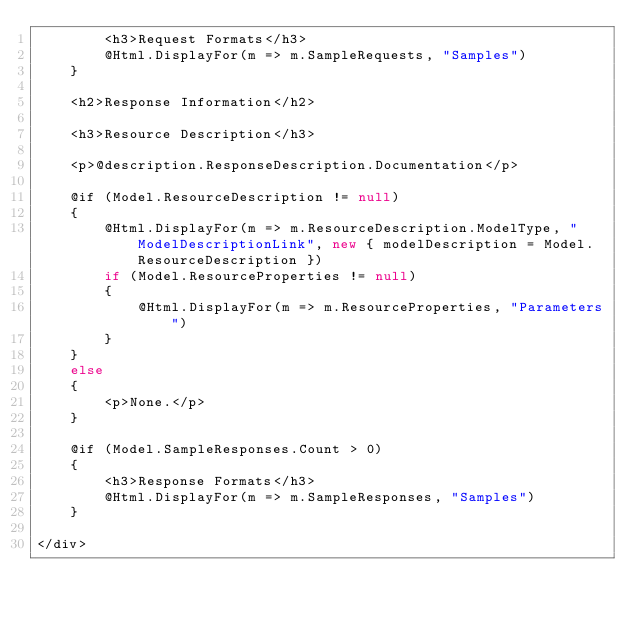<code> <loc_0><loc_0><loc_500><loc_500><_C#_>        <h3>Request Formats</h3>
        @Html.DisplayFor(m => m.SampleRequests, "Samples")
    }

    <h2>Response Information</h2>

    <h3>Resource Description</h3>

    <p>@description.ResponseDescription.Documentation</p>

    @if (Model.ResourceDescription != null)
    {
        @Html.DisplayFor(m => m.ResourceDescription.ModelType, "ModelDescriptionLink", new { modelDescription = Model.ResourceDescription })
        if (Model.ResourceProperties != null)
        {
            @Html.DisplayFor(m => m.ResourceProperties, "Parameters")
        }
    }
    else
    {
        <p>None.</p>
    }

    @if (Model.SampleResponses.Count > 0)
    {
        <h3>Response Formats</h3>
        @Html.DisplayFor(m => m.SampleResponses, "Samples")
    }

</div></code> 